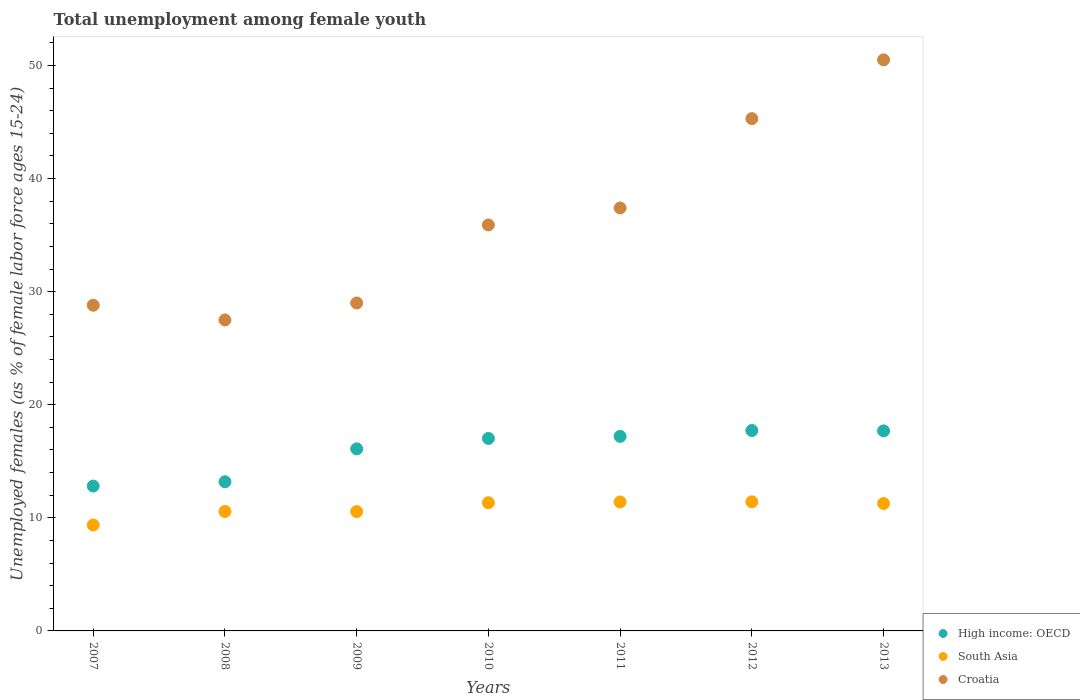How many different coloured dotlines are there?
Your response must be concise. 3. Is the number of dotlines equal to the number of legend labels?
Your response must be concise. Yes. What is the percentage of unemployed females in in South Asia in 2007?
Your answer should be compact. 9.37. Across all years, what is the maximum percentage of unemployed females in in Croatia?
Give a very brief answer. 50.5. Across all years, what is the minimum percentage of unemployed females in in South Asia?
Offer a terse response. 9.37. What is the total percentage of unemployed females in in South Asia in the graph?
Provide a succinct answer. 75.91. What is the difference between the percentage of unemployed females in in South Asia in 2008 and that in 2009?
Offer a very short reply. 0.01. What is the difference between the percentage of unemployed females in in Croatia in 2007 and the percentage of unemployed females in in High income: OECD in 2010?
Make the answer very short. 11.78. What is the average percentage of unemployed females in in Croatia per year?
Provide a short and direct response. 36.34. In the year 2007, what is the difference between the percentage of unemployed females in in South Asia and percentage of unemployed females in in Croatia?
Provide a succinct answer. -19.43. In how many years, is the percentage of unemployed females in in Croatia greater than 44 %?
Keep it short and to the point. 2. What is the ratio of the percentage of unemployed females in in South Asia in 2010 to that in 2013?
Make the answer very short. 1.01. What is the difference between the highest and the second highest percentage of unemployed females in in South Asia?
Your response must be concise. 0.01. Is it the case that in every year, the sum of the percentage of unemployed females in in South Asia and percentage of unemployed females in in Croatia  is greater than the percentage of unemployed females in in High income: OECD?
Offer a terse response. Yes. Does the percentage of unemployed females in in South Asia monotonically increase over the years?
Offer a terse response. No. Is the percentage of unemployed females in in South Asia strictly less than the percentage of unemployed females in in Croatia over the years?
Make the answer very short. Yes. How many years are there in the graph?
Offer a very short reply. 7. Are the values on the major ticks of Y-axis written in scientific E-notation?
Offer a terse response. No. Does the graph contain any zero values?
Keep it short and to the point. No. Where does the legend appear in the graph?
Make the answer very short. Bottom right. How are the legend labels stacked?
Ensure brevity in your answer.  Vertical. What is the title of the graph?
Your answer should be very brief. Total unemployment among female youth. Does "Caribbean small states" appear as one of the legend labels in the graph?
Provide a succinct answer. No. What is the label or title of the Y-axis?
Make the answer very short. Unemployed females (as % of female labor force ages 15-24). What is the Unemployed females (as % of female labor force ages 15-24) of High income: OECD in 2007?
Your answer should be very brief. 12.81. What is the Unemployed females (as % of female labor force ages 15-24) in South Asia in 2007?
Ensure brevity in your answer.  9.37. What is the Unemployed females (as % of female labor force ages 15-24) of Croatia in 2007?
Make the answer very short. 28.8. What is the Unemployed females (as % of female labor force ages 15-24) in High income: OECD in 2008?
Your answer should be very brief. 13.19. What is the Unemployed females (as % of female labor force ages 15-24) of South Asia in 2008?
Offer a very short reply. 10.56. What is the Unemployed females (as % of female labor force ages 15-24) in Croatia in 2008?
Provide a short and direct response. 27.5. What is the Unemployed females (as % of female labor force ages 15-24) of High income: OECD in 2009?
Make the answer very short. 16.1. What is the Unemployed females (as % of female labor force ages 15-24) of South Asia in 2009?
Provide a short and direct response. 10.55. What is the Unemployed females (as % of female labor force ages 15-24) of Croatia in 2009?
Your answer should be compact. 29. What is the Unemployed females (as % of female labor force ages 15-24) in High income: OECD in 2010?
Your answer should be very brief. 17.02. What is the Unemployed females (as % of female labor force ages 15-24) in South Asia in 2010?
Provide a short and direct response. 11.34. What is the Unemployed females (as % of female labor force ages 15-24) of Croatia in 2010?
Give a very brief answer. 35.9. What is the Unemployed females (as % of female labor force ages 15-24) of High income: OECD in 2011?
Offer a very short reply. 17.2. What is the Unemployed females (as % of female labor force ages 15-24) in South Asia in 2011?
Provide a succinct answer. 11.4. What is the Unemployed females (as % of female labor force ages 15-24) in Croatia in 2011?
Ensure brevity in your answer.  37.4. What is the Unemployed females (as % of female labor force ages 15-24) of High income: OECD in 2012?
Your answer should be compact. 17.72. What is the Unemployed females (as % of female labor force ages 15-24) in South Asia in 2012?
Offer a terse response. 11.42. What is the Unemployed females (as % of female labor force ages 15-24) in Croatia in 2012?
Keep it short and to the point. 45.3. What is the Unemployed females (as % of female labor force ages 15-24) of High income: OECD in 2013?
Make the answer very short. 17.69. What is the Unemployed females (as % of female labor force ages 15-24) of South Asia in 2013?
Provide a succinct answer. 11.27. What is the Unemployed females (as % of female labor force ages 15-24) in Croatia in 2013?
Provide a succinct answer. 50.5. Across all years, what is the maximum Unemployed females (as % of female labor force ages 15-24) of High income: OECD?
Offer a terse response. 17.72. Across all years, what is the maximum Unemployed females (as % of female labor force ages 15-24) of South Asia?
Make the answer very short. 11.42. Across all years, what is the maximum Unemployed females (as % of female labor force ages 15-24) in Croatia?
Provide a succinct answer. 50.5. Across all years, what is the minimum Unemployed females (as % of female labor force ages 15-24) of High income: OECD?
Ensure brevity in your answer.  12.81. Across all years, what is the minimum Unemployed females (as % of female labor force ages 15-24) in South Asia?
Offer a very short reply. 9.37. Across all years, what is the minimum Unemployed females (as % of female labor force ages 15-24) in Croatia?
Your response must be concise. 27.5. What is the total Unemployed females (as % of female labor force ages 15-24) in High income: OECD in the graph?
Give a very brief answer. 111.73. What is the total Unemployed females (as % of female labor force ages 15-24) of South Asia in the graph?
Ensure brevity in your answer.  75.91. What is the total Unemployed females (as % of female labor force ages 15-24) in Croatia in the graph?
Give a very brief answer. 254.4. What is the difference between the Unemployed females (as % of female labor force ages 15-24) of High income: OECD in 2007 and that in 2008?
Provide a succinct answer. -0.38. What is the difference between the Unemployed females (as % of female labor force ages 15-24) of South Asia in 2007 and that in 2008?
Your response must be concise. -1.2. What is the difference between the Unemployed females (as % of female labor force ages 15-24) of High income: OECD in 2007 and that in 2009?
Offer a terse response. -3.29. What is the difference between the Unemployed females (as % of female labor force ages 15-24) of South Asia in 2007 and that in 2009?
Your answer should be very brief. -1.19. What is the difference between the Unemployed females (as % of female labor force ages 15-24) of High income: OECD in 2007 and that in 2010?
Make the answer very short. -4.21. What is the difference between the Unemployed females (as % of female labor force ages 15-24) in South Asia in 2007 and that in 2010?
Your answer should be compact. -1.97. What is the difference between the Unemployed females (as % of female labor force ages 15-24) in Croatia in 2007 and that in 2010?
Ensure brevity in your answer.  -7.1. What is the difference between the Unemployed females (as % of female labor force ages 15-24) in High income: OECD in 2007 and that in 2011?
Your answer should be very brief. -4.39. What is the difference between the Unemployed females (as % of female labor force ages 15-24) in South Asia in 2007 and that in 2011?
Give a very brief answer. -2.04. What is the difference between the Unemployed females (as % of female labor force ages 15-24) of Croatia in 2007 and that in 2011?
Offer a very short reply. -8.6. What is the difference between the Unemployed females (as % of female labor force ages 15-24) of High income: OECD in 2007 and that in 2012?
Provide a succinct answer. -4.91. What is the difference between the Unemployed females (as % of female labor force ages 15-24) of South Asia in 2007 and that in 2012?
Your answer should be compact. -2.05. What is the difference between the Unemployed females (as % of female labor force ages 15-24) of Croatia in 2007 and that in 2012?
Your answer should be compact. -16.5. What is the difference between the Unemployed females (as % of female labor force ages 15-24) of High income: OECD in 2007 and that in 2013?
Your response must be concise. -4.88. What is the difference between the Unemployed females (as % of female labor force ages 15-24) in South Asia in 2007 and that in 2013?
Your answer should be compact. -1.9. What is the difference between the Unemployed females (as % of female labor force ages 15-24) of Croatia in 2007 and that in 2013?
Provide a succinct answer. -21.7. What is the difference between the Unemployed females (as % of female labor force ages 15-24) of High income: OECD in 2008 and that in 2009?
Give a very brief answer. -2.91. What is the difference between the Unemployed females (as % of female labor force ages 15-24) in South Asia in 2008 and that in 2009?
Make the answer very short. 0.01. What is the difference between the Unemployed females (as % of female labor force ages 15-24) in High income: OECD in 2008 and that in 2010?
Offer a very short reply. -3.83. What is the difference between the Unemployed females (as % of female labor force ages 15-24) of South Asia in 2008 and that in 2010?
Your answer should be compact. -0.77. What is the difference between the Unemployed females (as % of female labor force ages 15-24) of Croatia in 2008 and that in 2010?
Keep it short and to the point. -8.4. What is the difference between the Unemployed females (as % of female labor force ages 15-24) of High income: OECD in 2008 and that in 2011?
Keep it short and to the point. -4.01. What is the difference between the Unemployed females (as % of female labor force ages 15-24) in South Asia in 2008 and that in 2011?
Make the answer very short. -0.84. What is the difference between the Unemployed females (as % of female labor force ages 15-24) in High income: OECD in 2008 and that in 2012?
Your response must be concise. -4.53. What is the difference between the Unemployed females (as % of female labor force ages 15-24) of South Asia in 2008 and that in 2012?
Provide a succinct answer. -0.85. What is the difference between the Unemployed females (as % of female labor force ages 15-24) in Croatia in 2008 and that in 2012?
Your answer should be very brief. -17.8. What is the difference between the Unemployed females (as % of female labor force ages 15-24) of High income: OECD in 2008 and that in 2013?
Offer a very short reply. -4.5. What is the difference between the Unemployed females (as % of female labor force ages 15-24) in South Asia in 2008 and that in 2013?
Your answer should be very brief. -0.7. What is the difference between the Unemployed females (as % of female labor force ages 15-24) in Croatia in 2008 and that in 2013?
Your response must be concise. -23. What is the difference between the Unemployed females (as % of female labor force ages 15-24) in High income: OECD in 2009 and that in 2010?
Offer a terse response. -0.92. What is the difference between the Unemployed females (as % of female labor force ages 15-24) in South Asia in 2009 and that in 2010?
Offer a very short reply. -0.78. What is the difference between the Unemployed females (as % of female labor force ages 15-24) in Croatia in 2009 and that in 2010?
Offer a very short reply. -6.9. What is the difference between the Unemployed females (as % of female labor force ages 15-24) in High income: OECD in 2009 and that in 2011?
Keep it short and to the point. -1.1. What is the difference between the Unemployed females (as % of female labor force ages 15-24) of South Asia in 2009 and that in 2011?
Give a very brief answer. -0.85. What is the difference between the Unemployed females (as % of female labor force ages 15-24) in Croatia in 2009 and that in 2011?
Your answer should be compact. -8.4. What is the difference between the Unemployed females (as % of female labor force ages 15-24) of High income: OECD in 2009 and that in 2012?
Offer a terse response. -1.62. What is the difference between the Unemployed females (as % of female labor force ages 15-24) of South Asia in 2009 and that in 2012?
Ensure brevity in your answer.  -0.87. What is the difference between the Unemployed females (as % of female labor force ages 15-24) of Croatia in 2009 and that in 2012?
Your answer should be compact. -16.3. What is the difference between the Unemployed females (as % of female labor force ages 15-24) of High income: OECD in 2009 and that in 2013?
Provide a short and direct response. -1.59. What is the difference between the Unemployed females (as % of female labor force ages 15-24) of South Asia in 2009 and that in 2013?
Give a very brief answer. -0.72. What is the difference between the Unemployed females (as % of female labor force ages 15-24) of Croatia in 2009 and that in 2013?
Keep it short and to the point. -21.5. What is the difference between the Unemployed females (as % of female labor force ages 15-24) in High income: OECD in 2010 and that in 2011?
Provide a short and direct response. -0.18. What is the difference between the Unemployed females (as % of female labor force ages 15-24) of South Asia in 2010 and that in 2011?
Offer a terse response. -0.07. What is the difference between the Unemployed females (as % of female labor force ages 15-24) in High income: OECD in 2010 and that in 2012?
Provide a short and direct response. -0.7. What is the difference between the Unemployed females (as % of female labor force ages 15-24) in South Asia in 2010 and that in 2012?
Ensure brevity in your answer.  -0.08. What is the difference between the Unemployed females (as % of female labor force ages 15-24) in High income: OECD in 2010 and that in 2013?
Offer a terse response. -0.67. What is the difference between the Unemployed females (as % of female labor force ages 15-24) in South Asia in 2010 and that in 2013?
Your answer should be compact. 0.07. What is the difference between the Unemployed females (as % of female labor force ages 15-24) in Croatia in 2010 and that in 2013?
Provide a succinct answer. -14.6. What is the difference between the Unemployed females (as % of female labor force ages 15-24) in High income: OECD in 2011 and that in 2012?
Keep it short and to the point. -0.52. What is the difference between the Unemployed females (as % of female labor force ages 15-24) in South Asia in 2011 and that in 2012?
Make the answer very short. -0.01. What is the difference between the Unemployed females (as % of female labor force ages 15-24) in High income: OECD in 2011 and that in 2013?
Your response must be concise. -0.49. What is the difference between the Unemployed females (as % of female labor force ages 15-24) of South Asia in 2011 and that in 2013?
Provide a succinct answer. 0.14. What is the difference between the Unemployed females (as % of female labor force ages 15-24) of Croatia in 2011 and that in 2013?
Your response must be concise. -13.1. What is the difference between the Unemployed females (as % of female labor force ages 15-24) in High income: OECD in 2012 and that in 2013?
Give a very brief answer. 0.03. What is the difference between the Unemployed females (as % of female labor force ages 15-24) in South Asia in 2012 and that in 2013?
Your answer should be compact. 0.15. What is the difference between the Unemployed females (as % of female labor force ages 15-24) of Croatia in 2012 and that in 2013?
Make the answer very short. -5.2. What is the difference between the Unemployed females (as % of female labor force ages 15-24) in High income: OECD in 2007 and the Unemployed females (as % of female labor force ages 15-24) in South Asia in 2008?
Offer a very short reply. 2.25. What is the difference between the Unemployed females (as % of female labor force ages 15-24) in High income: OECD in 2007 and the Unemployed females (as % of female labor force ages 15-24) in Croatia in 2008?
Provide a short and direct response. -14.69. What is the difference between the Unemployed females (as % of female labor force ages 15-24) of South Asia in 2007 and the Unemployed females (as % of female labor force ages 15-24) of Croatia in 2008?
Your response must be concise. -18.13. What is the difference between the Unemployed females (as % of female labor force ages 15-24) in High income: OECD in 2007 and the Unemployed females (as % of female labor force ages 15-24) in South Asia in 2009?
Your answer should be very brief. 2.26. What is the difference between the Unemployed females (as % of female labor force ages 15-24) of High income: OECD in 2007 and the Unemployed females (as % of female labor force ages 15-24) of Croatia in 2009?
Your response must be concise. -16.19. What is the difference between the Unemployed females (as % of female labor force ages 15-24) of South Asia in 2007 and the Unemployed females (as % of female labor force ages 15-24) of Croatia in 2009?
Give a very brief answer. -19.63. What is the difference between the Unemployed females (as % of female labor force ages 15-24) of High income: OECD in 2007 and the Unemployed females (as % of female labor force ages 15-24) of South Asia in 2010?
Provide a succinct answer. 1.47. What is the difference between the Unemployed females (as % of female labor force ages 15-24) of High income: OECD in 2007 and the Unemployed females (as % of female labor force ages 15-24) of Croatia in 2010?
Give a very brief answer. -23.09. What is the difference between the Unemployed females (as % of female labor force ages 15-24) in South Asia in 2007 and the Unemployed females (as % of female labor force ages 15-24) in Croatia in 2010?
Your answer should be compact. -26.53. What is the difference between the Unemployed females (as % of female labor force ages 15-24) of High income: OECD in 2007 and the Unemployed females (as % of female labor force ages 15-24) of South Asia in 2011?
Offer a very short reply. 1.4. What is the difference between the Unemployed females (as % of female labor force ages 15-24) of High income: OECD in 2007 and the Unemployed females (as % of female labor force ages 15-24) of Croatia in 2011?
Provide a succinct answer. -24.59. What is the difference between the Unemployed females (as % of female labor force ages 15-24) in South Asia in 2007 and the Unemployed females (as % of female labor force ages 15-24) in Croatia in 2011?
Provide a succinct answer. -28.03. What is the difference between the Unemployed females (as % of female labor force ages 15-24) in High income: OECD in 2007 and the Unemployed females (as % of female labor force ages 15-24) in South Asia in 2012?
Give a very brief answer. 1.39. What is the difference between the Unemployed females (as % of female labor force ages 15-24) of High income: OECD in 2007 and the Unemployed females (as % of female labor force ages 15-24) of Croatia in 2012?
Keep it short and to the point. -32.49. What is the difference between the Unemployed females (as % of female labor force ages 15-24) in South Asia in 2007 and the Unemployed females (as % of female labor force ages 15-24) in Croatia in 2012?
Ensure brevity in your answer.  -35.93. What is the difference between the Unemployed females (as % of female labor force ages 15-24) in High income: OECD in 2007 and the Unemployed females (as % of female labor force ages 15-24) in South Asia in 2013?
Give a very brief answer. 1.54. What is the difference between the Unemployed females (as % of female labor force ages 15-24) of High income: OECD in 2007 and the Unemployed females (as % of female labor force ages 15-24) of Croatia in 2013?
Offer a terse response. -37.69. What is the difference between the Unemployed females (as % of female labor force ages 15-24) in South Asia in 2007 and the Unemployed females (as % of female labor force ages 15-24) in Croatia in 2013?
Give a very brief answer. -41.13. What is the difference between the Unemployed females (as % of female labor force ages 15-24) in High income: OECD in 2008 and the Unemployed females (as % of female labor force ages 15-24) in South Asia in 2009?
Offer a terse response. 2.64. What is the difference between the Unemployed females (as % of female labor force ages 15-24) in High income: OECD in 2008 and the Unemployed females (as % of female labor force ages 15-24) in Croatia in 2009?
Keep it short and to the point. -15.81. What is the difference between the Unemployed females (as % of female labor force ages 15-24) in South Asia in 2008 and the Unemployed females (as % of female labor force ages 15-24) in Croatia in 2009?
Provide a short and direct response. -18.44. What is the difference between the Unemployed females (as % of female labor force ages 15-24) of High income: OECD in 2008 and the Unemployed females (as % of female labor force ages 15-24) of South Asia in 2010?
Keep it short and to the point. 1.85. What is the difference between the Unemployed females (as % of female labor force ages 15-24) of High income: OECD in 2008 and the Unemployed females (as % of female labor force ages 15-24) of Croatia in 2010?
Ensure brevity in your answer.  -22.71. What is the difference between the Unemployed females (as % of female labor force ages 15-24) in South Asia in 2008 and the Unemployed females (as % of female labor force ages 15-24) in Croatia in 2010?
Your answer should be very brief. -25.34. What is the difference between the Unemployed females (as % of female labor force ages 15-24) in High income: OECD in 2008 and the Unemployed females (as % of female labor force ages 15-24) in South Asia in 2011?
Offer a very short reply. 1.78. What is the difference between the Unemployed females (as % of female labor force ages 15-24) in High income: OECD in 2008 and the Unemployed females (as % of female labor force ages 15-24) in Croatia in 2011?
Provide a short and direct response. -24.21. What is the difference between the Unemployed females (as % of female labor force ages 15-24) of South Asia in 2008 and the Unemployed females (as % of female labor force ages 15-24) of Croatia in 2011?
Provide a short and direct response. -26.84. What is the difference between the Unemployed females (as % of female labor force ages 15-24) in High income: OECD in 2008 and the Unemployed females (as % of female labor force ages 15-24) in South Asia in 2012?
Keep it short and to the point. 1.77. What is the difference between the Unemployed females (as % of female labor force ages 15-24) of High income: OECD in 2008 and the Unemployed females (as % of female labor force ages 15-24) of Croatia in 2012?
Keep it short and to the point. -32.11. What is the difference between the Unemployed females (as % of female labor force ages 15-24) of South Asia in 2008 and the Unemployed females (as % of female labor force ages 15-24) of Croatia in 2012?
Your response must be concise. -34.74. What is the difference between the Unemployed females (as % of female labor force ages 15-24) of High income: OECD in 2008 and the Unemployed females (as % of female labor force ages 15-24) of South Asia in 2013?
Provide a succinct answer. 1.92. What is the difference between the Unemployed females (as % of female labor force ages 15-24) in High income: OECD in 2008 and the Unemployed females (as % of female labor force ages 15-24) in Croatia in 2013?
Provide a short and direct response. -37.31. What is the difference between the Unemployed females (as % of female labor force ages 15-24) of South Asia in 2008 and the Unemployed females (as % of female labor force ages 15-24) of Croatia in 2013?
Ensure brevity in your answer.  -39.94. What is the difference between the Unemployed females (as % of female labor force ages 15-24) in High income: OECD in 2009 and the Unemployed females (as % of female labor force ages 15-24) in South Asia in 2010?
Make the answer very short. 4.76. What is the difference between the Unemployed females (as % of female labor force ages 15-24) of High income: OECD in 2009 and the Unemployed females (as % of female labor force ages 15-24) of Croatia in 2010?
Provide a short and direct response. -19.8. What is the difference between the Unemployed females (as % of female labor force ages 15-24) in South Asia in 2009 and the Unemployed females (as % of female labor force ages 15-24) in Croatia in 2010?
Offer a terse response. -25.35. What is the difference between the Unemployed females (as % of female labor force ages 15-24) of High income: OECD in 2009 and the Unemployed females (as % of female labor force ages 15-24) of South Asia in 2011?
Make the answer very short. 4.7. What is the difference between the Unemployed females (as % of female labor force ages 15-24) of High income: OECD in 2009 and the Unemployed females (as % of female labor force ages 15-24) of Croatia in 2011?
Offer a terse response. -21.3. What is the difference between the Unemployed females (as % of female labor force ages 15-24) of South Asia in 2009 and the Unemployed females (as % of female labor force ages 15-24) of Croatia in 2011?
Provide a short and direct response. -26.85. What is the difference between the Unemployed females (as % of female labor force ages 15-24) of High income: OECD in 2009 and the Unemployed females (as % of female labor force ages 15-24) of South Asia in 2012?
Keep it short and to the point. 4.68. What is the difference between the Unemployed females (as % of female labor force ages 15-24) of High income: OECD in 2009 and the Unemployed females (as % of female labor force ages 15-24) of Croatia in 2012?
Your answer should be very brief. -29.2. What is the difference between the Unemployed females (as % of female labor force ages 15-24) of South Asia in 2009 and the Unemployed females (as % of female labor force ages 15-24) of Croatia in 2012?
Provide a succinct answer. -34.75. What is the difference between the Unemployed females (as % of female labor force ages 15-24) of High income: OECD in 2009 and the Unemployed females (as % of female labor force ages 15-24) of South Asia in 2013?
Offer a very short reply. 4.83. What is the difference between the Unemployed females (as % of female labor force ages 15-24) in High income: OECD in 2009 and the Unemployed females (as % of female labor force ages 15-24) in Croatia in 2013?
Keep it short and to the point. -34.4. What is the difference between the Unemployed females (as % of female labor force ages 15-24) of South Asia in 2009 and the Unemployed females (as % of female labor force ages 15-24) of Croatia in 2013?
Ensure brevity in your answer.  -39.95. What is the difference between the Unemployed females (as % of female labor force ages 15-24) in High income: OECD in 2010 and the Unemployed females (as % of female labor force ages 15-24) in South Asia in 2011?
Ensure brevity in your answer.  5.62. What is the difference between the Unemployed females (as % of female labor force ages 15-24) in High income: OECD in 2010 and the Unemployed females (as % of female labor force ages 15-24) in Croatia in 2011?
Keep it short and to the point. -20.38. What is the difference between the Unemployed females (as % of female labor force ages 15-24) in South Asia in 2010 and the Unemployed females (as % of female labor force ages 15-24) in Croatia in 2011?
Offer a terse response. -26.06. What is the difference between the Unemployed females (as % of female labor force ages 15-24) of High income: OECD in 2010 and the Unemployed females (as % of female labor force ages 15-24) of South Asia in 2012?
Offer a very short reply. 5.6. What is the difference between the Unemployed females (as % of female labor force ages 15-24) of High income: OECD in 2010 and the Unemployed females (as % of female labor force ages 15-24) of Croatia in 2012?
Make the answer very short. -28.28. What is the difference between the Unemployed females (as % of female labor force ages 15-24) of South Asia in 2010 and the Unemployed females (as % of female labor force ages 15-24) of Croatia in 2012?
Make the answer very short. -33.96. What is the difference between the Unemployed females (as % of female labor force ages 15-24) in High income: OECD in 2010 and the Unemployed females (as % of female labor force ages 15-24) in South Asia in 2013?
Your response must be concise. 5.75. What is the difference between the Unemployed females (as % of female labor force ages 15-24) in High income: OECD in 2010 and the Unemployed females (as % of female labor force ages 15-24) in Croatia in 2013?
Offer a very short reply. -33.48. What is the difference between the Unemployed females (as % of female labor force ages 15-24) in South Asia in 2010 and the Unemployed females (as % of female labor force ages 15-24) in Croatia in 2013?
Make the answer very short. -39.16. What is the difference between the Unemployed females (as % of female labor force ages 15-24) of High income: OECD in 2011 and the Unemployed females (as % of female labor force ages 15-24) of South Asia in 2012?
Provide a succinct answer. 5.78. What is the difference between the Unemployed females (as % of female labor force ages 15-24) in High income: OECD in 2011 and the Unemployed females (as % of female labor force ages 15-24) in Croatia in 2012?
Provide a succinct answer. -28.1. What is the difference between the Unemployed females (as % of female labor force ages 15-24) in South Asia in 2011 and the Unemployed females (as % of female labor force ages 15-24) in Croatia in 2012?
Your answer should be compact. -33.9. What is the difference between the Unemployed females (as % of female labor force ages 15-24) of High income: OECD in 2011 and the Unemployed females (as % of female labor force ages 15-24) of South Asia in 2013?
Provide a short and direct response. 5.93. What is the difference between the Unemployed females (as % of female labor force ages 15-24) of High income: OECD in 2011 and the Unemployed females (as % of female labor force ages 15-24) of Croatia in 2013?
Provide a succinct answer. -33.3. What is the difference between the Unemployed females (as % of female labor force ages 15-24) in South Asia in 2011 and the Unemployed females (as % of female labor force ages 15-24) in Croatia in 2013?
Provide a short and direct response. -39.1. What is the difference between the Unemployed females (as % of female labor force ages 15-24) in High income: OECD in 2012 and the Unemployed females (as % of female labor force ages 15-24) in South Asia in 2013?
Offer a very short reply. 6.45. What is the difference between the Unemployed females (as % of female labor force ages 15-24) of High income: OECD in 2012 and the Unemployed females (as % of female labor force ages 15-24) of Croatia in 2013?
Keep it short and to the point. -32.78. What is the difference between the Unemployed females (as % of female labor force ages 15-24) of South Asia in 2012 and the Unemployed females (as % of female labor force ages 15-24) of Croatia in 2013?
Provide a succinct answer. -39.08. What is the average Unemployed females (as % of female labor force ages 15-24) in High income: OECD per year?
Ensure brevity in your answer.  15.96. What is the average Unemployed females (as % of female labor force ages 15-24) in South Asia per year?
Offer a terse response. 10.84. What is the average Unemployed females (as % of female labor force ages 15-24) of Croatia per year?
Keep it short and to the point. 36.34. In the year 2007, what is the difference between the Unemployed females (as % of female labor force ages 15-24) in High income: OECD and Unemployed females (as % of female labor force ages 15-24) in South Asia?
Provide a succinct answer. 3.44. In the year 2007, what is the difference between the Unemployed females (as % of female labor force ages 15-24) of High income: OECD and Unemployed females (as % of female labor force ages 15-24) of Croatia?
Offer a very short reply. -15.99. In the year 2007, what is the difference between the Unemployed females (as % of female labor force ages 15-24) of South Asia and Unemployed females (as % of female labor force ages 15-24) of Croatia?
Offer a terse response. -19.43. In the year 2008, what is the difference between the Unemployed females (as % of female labor force ages 15-24) of High income: OECD and Unemployed females (as % of female labor force ages 15-24) of South Asia?
Provide a short and direct response. 2.63. In the year 2008, what is the difference between the Unemployed females (as % of female labor force ages 15-24) of High income: OECD and Unemployed females (as % of female labor force ages 15-24) of Croatia?
Offer a terse response. -14.31. In the year 2008, what is the difference between the Unemployed females (as % of female labor force ages 15-24) in South Asia and Unemployed females (as % of female labor force ages 15-24) in Croatia?
Offer a terse response. -16.94. In the year 2009, what is the difference between the Unemployed females (as % of female labor force ages 15-24) of High income: OECD and Unemployed females (as % of female labor force ages 15-24) of South Asia?
Make the answer very short. 5.55. In the year 2009, what is the difference between the Unemployed females (as % of female labor force ages 15-24) in High income: OECD and Unemployed females (as % of female labor force ages 15-24) in Croatia?
Offer a terse response. -12.9. In the year 2009, what is the difference between the Unemployed females (as % of female labor force ages 15-24) of South Asia and Unemployed females (as % of female labor force ages 15-24) of Croatia?
Provide a short and direct response. -18.45. In the year 2010, what is the difference between the Unemployed females (as % of female labor force ages 15-24) in High income: OECD and Unemployed females (as % of female labor force ages 15-24) in South Asia?
Provide a short and direct response. 5.69. In the year 2010, what is the difference between the Unemployed females (as % of female labor force ages 15-24) in High income: OECD and Unemployed females (as % of female labor force ages 15-24) in Croatia?
Your answer should be very brief. -18.88. In the year 2010, what is the difference between the Unemployed females (as % of female labor force ages 15-24) in South Asia and Unemployed females (as % of female labor force ages 15-24) in Croatia?
Provide a succinct answer. -24.56. In the year 2011, what is the difference between the Unemployed females (as % of female labor force ages 15-24) in High income: OECD and Unemployed females (as % of female labor force ages 15-24) in South Asia?
Offer a very short reply. 5.8. In the year 2011, what is the difference between the Unemployed females (as % of female labor force ages 15-24) in High income: OECD and Unemployed females (as % of female labor force ages 15-24) in Croatia?
Offer a very short reply. -20.2. In the year 2011, what is the difference between the Unemployed females (as % of female labor force ages 15-24) in South Asia and Unemployed females (as % of female labor force ages 15-24) in Croatia?
Provide a short and direct response. -26. In the year 2012, what is the difference between the Unemployed females (as % of female labor force ages 15-24) of High income: OECD and Unemployed females (as % of female labor force ages 15-24) of South Asia?
Keep it short and to the point. 6.3. In the year 2012, what is the difference between the Unemployed females (as % of female labor force ages 15-24) in High income: OECD and Unemployed females (as % of female labor force ages 15-24) in Croatia?
Offer a terse response. -27.58. In the year 2012, what is the difference between the Unemployed females (as % of female labor force ages 15-24) of South Asia and Unemployed females (as % of female labor force ages 15-24) of Croatia?
Make the answer very short. -33.88. In the year 2013, what is the difference between the Unemployed females (as % of female labor force ages 15-24) of High income: OECD and Unemployed females (as % of female labor force ages 15-24) of South Asia?
Offer a terse response. 6.42. In the year 2013, what is the difference between the Unemployed females (as % of female labor force ages 15-24) of High income: OECD and Unemployed females (as % of female labor force ages 15-24) of Croatia?
Provide a succinct answer. -32.81. In the year 2013, what is the difference between the Unemployed females (as % of female labor force ages 15-24) of South Asia and Unemployed females (as % of female labor force ages 15-24) of Croatia?
Provide a short and direct response. -39.23. What is the ratio of the Unemployed females (as % of female labor force ages 15-24) of High income: OECD in 2007 to that in 2008?
Your answer should be compact. 0.97. What is the ratio of the Unemployed females (as % of female labor force ages 15-24) in South Asia in 2007 to that in 2008?
Give a very brief answer. 0.89. What is the ratio of the Unemployed females (as % of female labor force ages 15-24) of Croatia in 2007 to that in 2008?
Your response must be concise. 1.05. What is the ratio of the Unemployed females (as % of female labor force ages 15-24) of High income: OECD in 2007 to that in 2009?
Your response must be concise. 0.8. What is the ratio of the Unemployed females (as % of female labor force ages 15-24) of South Asia in 2007 to that in 2009?
Your response must be concise. 0.89. What is the ratio of the Unemployed females (as % of female labor force ages 15-24) in High income: OECD in 2007 to that in 2010?
Your answer should be compact. 0.75. What is the ratio of the Unemployed females (as % of female labor force ages 15-24) of South Asia in 2007 to that in 2010?
Your response must be concise. 0.83. What is the ratio of the Unemployed females (as % of female labor force ages 15-24) in Croatia in 2007 to that in 2010?
Provide a succinct answer. 0.8. What is the ratio of the Unemployed females (as % of female labor force ages 15-24) of High income: OECD in 2007 to that in 2011?
Your response must be concise. 0.74. What is the ratio of the Unemployed females (as % of female labor force ages 15-24) of South Asia in 2007 to that in 2011?
Offer a terse response. 0.82. What is the ratio of the Unemployed females (as % of female labor force ages 15-24) in Croatia in 2007 to that in 2011?
Give a very brief answer. 0.77. What is the ratio of the Unemployed females (as % of female labor force ages 15-24) of High income: OECD in 2007 to that in 2012?
Ensure brevity in your answer.  0.72. What is the ratio of the Unemployed females (as % of female labor force ages 15-24) in South Asia in 2007 to that in 2012?
Give a very brief answer. 0.82. What is the ratio of the Unemployed females (as % of female labor force ages 15-24) in Croatia in 2007 to that in 2012?
Provide a succinct answer. 0.64. What is the ratio of the Unemployed females (as % of female labor force ages 15-24) of High income: OECD in 2007 to that in 2013?
Your answer should be compact. 0.72. What is the ratio of the Unemployed females (as % of female labor force ages 15-24) of South Asia in 2007 to that in 2013?
Provide a succinct answer. 0.83. What is the ratio of the Unemployed females (as % of female labor force ages 15-24) in Croatia in 2007 to that in 2013?
Your answer should be very brief. 0.57. What is the ratio of the Unemployed females (as % of female labor force ages 15-24) of High income: OECD in 2008 to that in 2009?
Provide a succinct answer. 0.82. What is the ratio of the Unemployed females (as % of female labor force ages 15-24) of South Asia in 2008 to that in 2009?
Make the answer very short. 1. What is the ratio of the Unemployed females (as % of female labor force ages 15-24) of Croatia in 2008 to that in 2009?
Your answer should be compact. 0.95. What is the ratio of the Unemployed females (as % of female labor force ages 15-24) of High income: OECD in 2008 to that in 2010?
Your answer should be very brief. 0.77. What is the ratio of the Unemployed females (as % of female labor force ages 15-24) of South Asia in 2008 to that in 2010?
Ensure brevity in your answer.  0.93. What is the ratio of the Unemployed females (as % of female labor force ages 15-24) of Croatia in 2008 to that in 2010?
Make the answer very short. 0.77. What is the ratio of the Unemployed females (as % of female labor force ages 15-24) in High income: OECD in 2008 to that in 2011?
Ensure brevity in your answer.  0.77. What is the ratio of the Unemployed females (as % of female labor force ages 15-24) of South Asia in 2008 to that in 2011?
Give a very brief answer. 0.93. What is the ratio of the Unemployed females (as % of female labor force ages 15-24) of Croatia in 2008 to that in 2011?
Make the answer very short. 0.74. What is the ratio of the Unemployed females (as % of female labor force ages 15-24) in High income: OECD in 2008 to that in 2012?
Your answer should be compact. 0.74. What is the ratio of the Unemployed females (as % of female labor force ages 15-24) of South Asia in 2008 to that in 2012?
Ensure brevity in your answer.  0.93. What is the ratio of the Unemployed females (as % of female labor force ages 15-24) in Croatia in 2008 to that in 2012?
Your response must be concise. 0.61. What is the ratio of the Unemployed females (as % of female labor force ages 15-24) in High income: OECD in 2008 to that in 2013?
Your answer should be very brief. 0.75. What is the ratio of the Unemployed females (as % of female labor force ages 15-24) in South Asia in 2008 to that in 2013?
Your answer should be compact. 0.94. What is the ratio of the Unemployed females (as % of female labor force ages 15-24) of Croatia in 2008 to that in 2013?
Provide a succinct answer. 0.54. What is the ratio of the Unemployed females (as % of female labor force ages 15-24) of High income: OECD in 2009 to that in 2010?
Your answer should be compact. 0.95. What is the ratio of the Unemployed females (as % of female labor force ages 15-24) of South Asia in 2009 to that in 2010?
Provide a short and direct response. 0.93. What is the ratio of the Unemployed females (as % of female labor force ages 15-24) in Croatia in 2009 to that in 2010?
Your answer should be compact. 0.81. What is the ratio of the Unemployed females (as % of female labor force ages 15-24) in High income: OECD in 2009 to that in 2011?
Offer a very short reply. 0.94. What is the ratio of the Unemployed females (as % of female labor force ages 15-24) of South Asia in 2009 to that in 2011?
Provide a succinct answer. 0.93. What is the ratio of the Unemployed females (as % of female labor force ages 15-24) of Croatia in 2009 to that in 2011?
Provide a short and direct response. 0.78. What is the ratio of the Unemployed females (as % of female labor force ages 15-24) in High income: OECD in 2009 to that in 2012?
Your response must be concise. 0.91. What is the ratio of the Unemployed females (as % of female labor force ages 15-24) in South Asia in 2009 to that in 2012?
Your answer should be compact. 0.92. What is the ratio of the Unemployed females (as % of female labor force ages 15-24) of Croatia in 2009 to that in 2012?
Ensure brevity in your answer.  0.64. What is the ratio of the Unemployed females (as % of female labor force ages 15-24) of High income: OECD in 2009 to that in 2013?
Give a very brief answer. 0.91. What is the ratio of the Unemployed females (as % of female labor force ages 15-24) of South Asia in 2009 to that in 2013?
Your response must be concise. 0.94. What is the ratio of the Unemployed females (as % of female labor force ages 15-24) of Croatia in 2009 to that in 2013?
Ensure brevity in your answer.  0.57. What is the ratio of the Unemployed females (as % of female labor force ages 15-24) in High income: OECD in 2010 to that in 2011?
Your answer should be very brief. 0.99. What is the ratio of the Unemployed females (as % of female labor force ages 15-24) in Croatia in 2010 to that in 2011?
Ensure brevity in your answer.  0.96. What is the ratio of the Unemployed females (as % of female labor force ages 15-24) of High income: OECD in 2010 to that in 2012?
Your answer should be compact. 0.96. What is the ratio of the Unemployed females (as % of female labor force ages 15-24) in Croatia in 2010 to that in 2012?
Keep it short and to the point. 0.79. What is the ratio of the Unemployed females (as % of female labor force ages 15-24) in High income: OECD in 2010 to that in 2013?
Offer a very short reply. 0.96. What is the ratio of the Unemployed females (as % of female labor force ages 15-24) of Croatia in 2010 to that in 2013?
Make the answer very short. 0.71. What is the ratio of the Unemployed females (as % of female labor force ages 15-24) in High income: OECD in 2011 to that in 2012?
Your answer should be compact. 0.97. What is the ratio of the Unemployed females (as % of female labor force ages 15-24) of Croatia in 2011 to that in 2012?
Your answer should be compact. 0.83. What is the ratio of the Unemployed females (as % of female labor force ages 15-24) in High income: OECD in 2011 to that in 2013?
Your answer should be compact. 0.97. What is the ratio of the Unemployed females (as % of female labor force ages 15-24) of South Asia in 2011 to that in 2013?
Ensure brevity in your answer.  1.01. What is the ratio of the Unemployed females (as % of female labor force ages 15-24) in Croatia in 2011 to that in 2013?
Your answer should be compact. 0.74. What is the ratio of the Unemployed females (as % of female labor force ages 15-24) of South Asia in 2012 to that in 2013?
Provide a short and direct response. 1.01. What is the ratio of the Unemployed females (as % of female labor force ages 15-24) in Croatia in 2012 to that in 2013?
Provide a short and direct response. 0.9. What is the difference between the highest and the second highest Unemployed females (as % of female labor force ages 15-24) in High income: OECD?
Provide a short and direct response. 0.03. What is the difference between the highest and the second highest Unemployed females (as % of female labor force ages 15-24) of South Asia?
Your response must be concise. 0.01. What is the difference between the highest and the lowest Unemployed females (as % of female labor force ages 15-24) of High income: OECD?
Ensure brevity in your answer.  4.91. What is the difference between the highest and the lowest Unemployed females (as % of female labor force ages 15-24) of South Asia?
Your response must be concise. 2.05. What is the difference between the highest and the lowest Unemployed females (as % of female labor force ages 15-24) of Croatia?
Give a very brief answer. 23. 